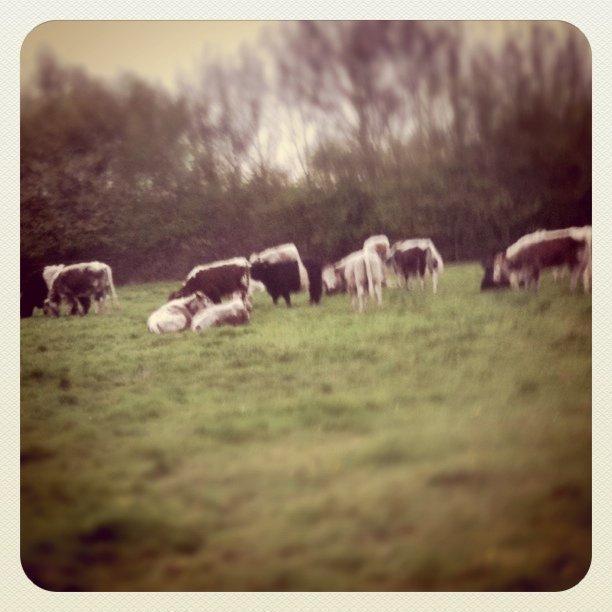How many cows can be seen?
Give a very brief answer. 6. 